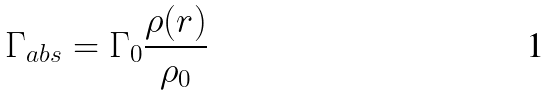Convert formula to latex. <formula><loc_0><loc_0><loc_500><loc_500>\Gamma _ { a b s } = \Gamma _ { 0 } \frac { \rho ( r ) } { \rho _ { 0 } }</formula> 